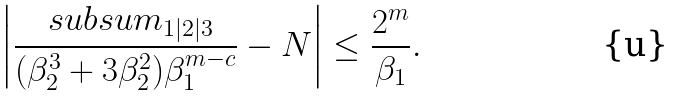<formula> <loc_0><loc_0><loc_500><loc_500>\left | \frac { \ s u b s u m _ { 1 | 2 | 3 } } { ( \beta _ { 2 } ^ { 3 } + 3 \beta _ { 2 } ^ { 2 } ) \beta _ { 1 } ^ { m - c } } - N \right | \leq \frac { 2 ^ { m } } { \beta _ { 1 } } .</formula> 